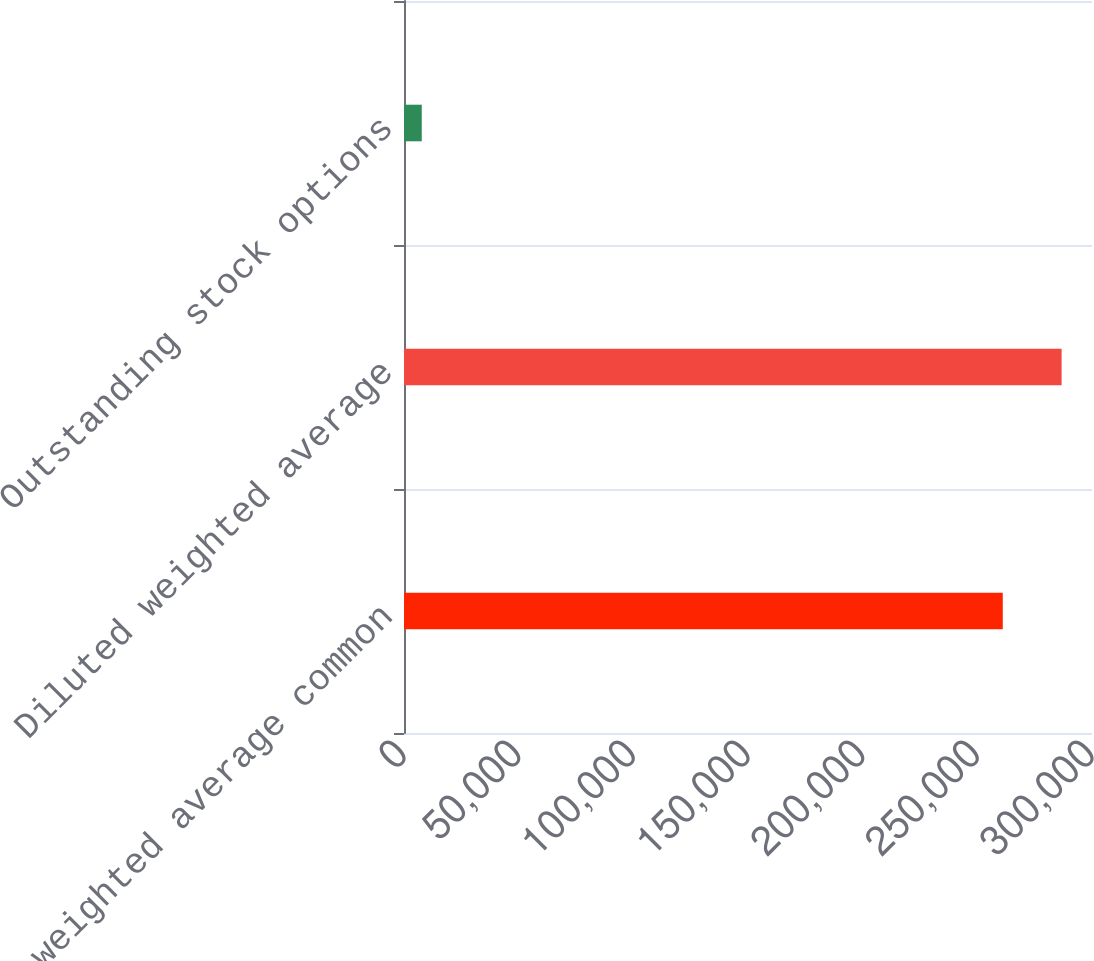Convert chart to OTSL. <chart><loc_0><loc_0><loc_500><loc_500><bar_chart><fcel>Basic weighted average common<fcel>Diluted weighted average<fcel>Outstanding stock options<nl><fcel>261099<fcel>286755<fcel>7747<nl></chart> 